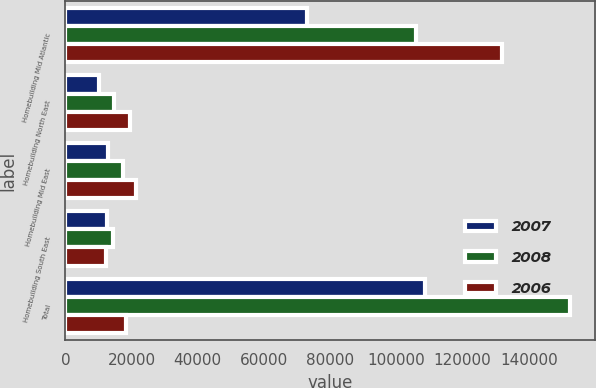<chart> <loc_0><loc_0><loc_500><loc_500><stacked_bar_chart><ecel><fcel>Homebuilding Mid Atlantic<fcel>Homebuilding North East<fcel>Homebuilding Mid East<fcel>Homebuilding South East<fcel>Total<nl><fcel>2007<fcel>73042<fcel>10081<fcel>12902<fcel>12484<fcel>108509<nl><fcel>2008<fcel>106032<fcel>14669<fcel>17381<fcel>14281<fcel>152363<nl><fcel>2006<fcel>131823<fcel>19533<fcel>21235<fcel>12317<fcel>18457<nl></chart> 